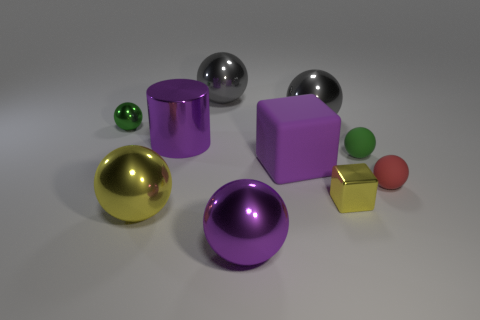Subtract all small matte spheres. How many spheres are left? 5 Subtract all spheres. How many objects are left? 3 Subtract 1 blocks. How many blocks are left? 1 Subtract all purple spheres. How many spheres are left? 6 Subtract all blue cylinders. How many purple balls are left? 1 Subtract all big blue metal balls. Subtract all shiny spheres. How many objects are left? 5 Add 7 large gray metallic spheres. How many large gray metallic spheres are left? 9 Add 2 tiny spheres. How many tiny spheres exist? 5 Subtract 1 purple spheres. How many objects are left? 9 Subtract all yellow cylinders. Subtract all green cubes. How many cylinders are left? 1 